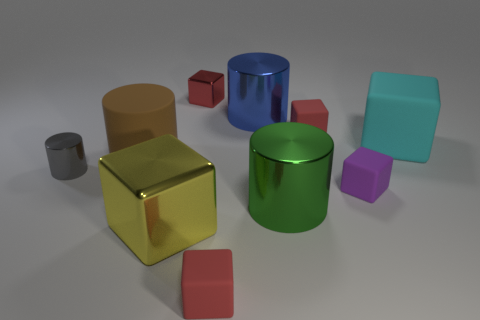Subtract all blue balls. How many red cubes are left? 3 Subtract 3 blocks. How many blocks are left? 3 Subtract all red matte blocks. How many blocks are left? 4 Subtract all yellow cubes. How many cubes are left? 5 Subtract all green blocks. Subtract all green cylinders. How many blocks are left? 6 Subtract all cylinders. How many objects are left? 6 Subtract all small gray cylinders. Subtract all big cyan cubes. How many objects are left? 8 Add 4 brown cylinders. How many brown cylinders are left? 5 Add 1 green shiny objects. How many green shiny objects exist? 2 Subtract 1 red cubes. How many objects are left? 9 